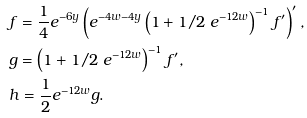<formula> <loc_0><loc_0><loc_500><loc_500>& f = \frac { 1 } { 4 } e ^ { - 6 y } \left ( e ^ { - 4 w - 4 y } \left ( 1 + 1 / 2 \ e ^ { - 1 2 w } \right ) ^ { - 1 } f ^ { \prime } \right ) ^ { \prime } , \\ & g = \left ( 1 + 1 / 2 \ e ^ { - 1 2 w } \right ) ^ { - 1 } f ^ { \prime } , \\ & h = \frac { 1 } { 2 } e ^ { - 1 2 w } g .</formula> 